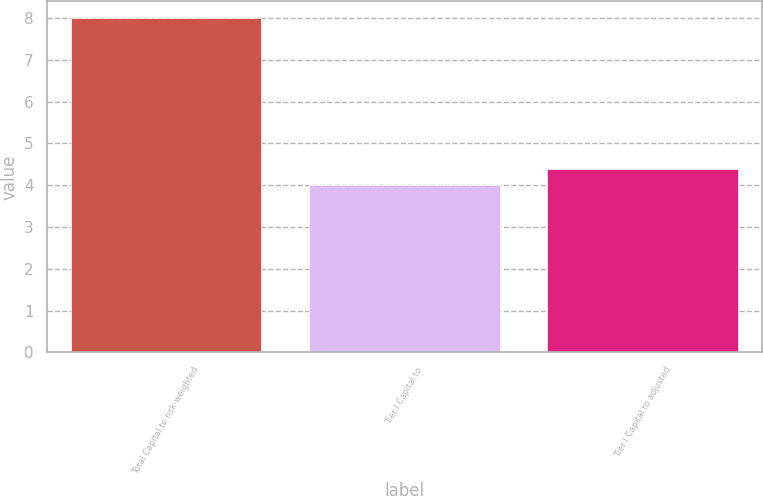Convert chart. <chart><loc_0><loc_0><loc_500><loc_500><bar_chart><fcel>Total Capital to risk-weighted<fcel>Tier I Capital to<fcel>Tier I Capital to adjusted<nl><fcel>8<fcel>4<fcel>4.4<nl></chart> 